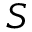Convert formula to latex. <formula><loc_0><loc_0><loc_500><loc_500>S</formula> 